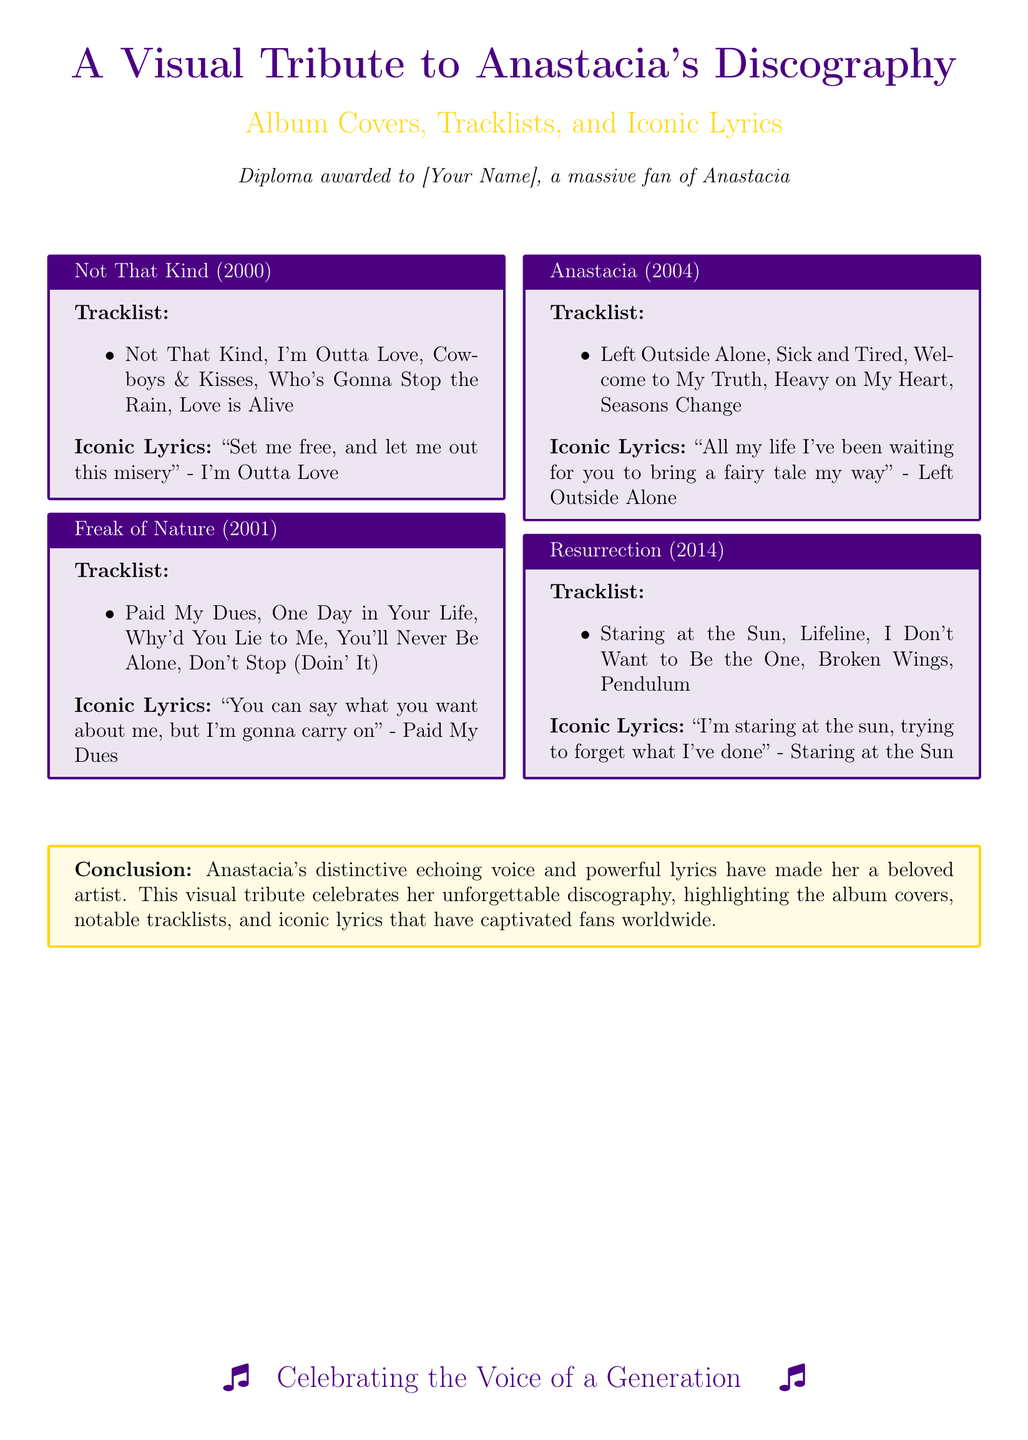what is the title of Anastacia's first album? The title of the first album mentioned in the document is "Not That Kind."
Answer: Not That Kind how many tracks are listed for the album "Resurrection"? The document lists five tracks for the album "Resurrection."
Answer: 5 what year was the album "Freak of Nature" released? The document states that the album "Freak of Nature" was released in 2001.
Answer: 2001 which song features the lyric "All my life I've been waiting for you to bring a fairy tale my way"? This lyric is from the song "Left Outside Alone" from the album "Anastacia."
Answer: Left Outside Alone what color is used for the conclusion box? The box uses an anastaciagold color for the background and frame.
Answer: anastaciagold which song includes the lyric "Set me free, and let me out this misery"? This lyric is from the song "I'm Outta Love" from the album "Not That Kind."
Answer: I'm Outta Love how many albums are featured in this visual tribute? The document features a total of four albums by Anastacia.
Answer: 4 what is the awarded diploma's focus? The diploma highlights Anastacia's album covers, tracklists, and iconic lyrics.
Answer: Album Covers, Tracklists, and Iconic Lyrics 